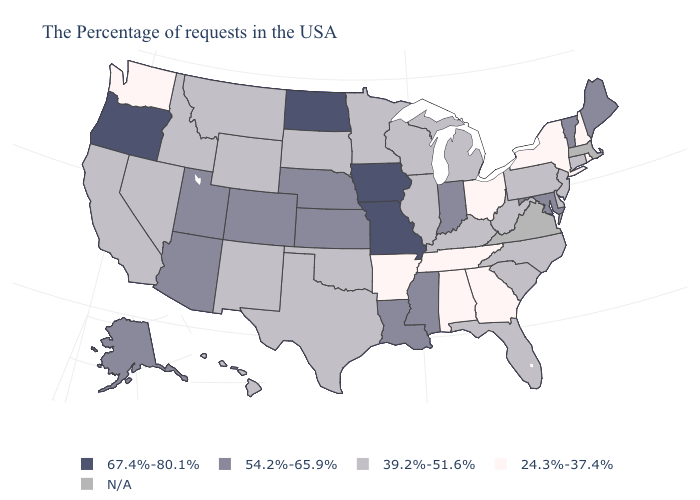Does New Hampshire have the lowest value in the USA?
Answer briefly. Yes. Does the first symbol in the legend represent the smallest category?
Concise answer only. No. Name the states that have a value in the range N/A?
Be succinct. Massachusetts, Virginia. What is the value of Mississippi?
Answer briefly. 54.2%-65.9%. Name the states that have a value in the range 67.4%-80.1%?
Short answer required. Missouri, Iowa, North Dakota, Oregon. What is the value of Tennessee?
Be succinct. 24.3%-37.4%. Name the states that have a value in the range 54.2%-65.9%?
Quick response, please. Maine, Vermont, Maryland, Indiana, Mississippi, Louisiana, Kansas, Nebraska, Colorado, Utah, Arizona, Alaska. Name the states that have a value in the range N/A?
Write a very short answer. Massachusetts, Virginia. Which states hav the highest value in the South?
Be succinct. Maryland, Mississippi, Louisiana. What is the value of Massachusetts?
Be succinct. N/A. Does New Hampshire have the highest value in the Northeast?
Short answer required. No. What is the value of Nevada?
Concise answer only. 39.2%-51.6%. What is the value of Colorado?
Answer briefly. 54.2%-65.9%. What is the highest value in the MidWest ?
Write a very short answer. 67.4%-80.1%. How many symbols are there in the legend?
Be succinct. 5. 